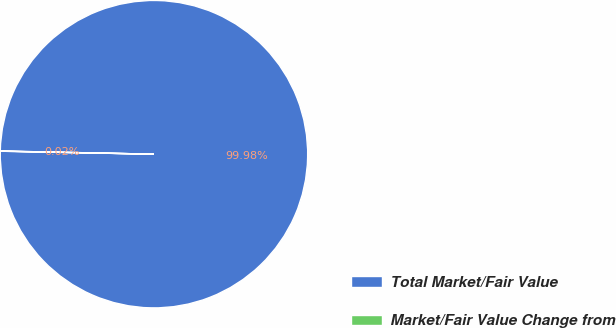Convert chart to OTSL. <chart><loc_0><loc_0><loc_500><loc_500><pie_chart><fcel>Total Market/Fair Value<fcel>Market/Fair Value Change from<nl><fcel>99.98%<fcel>0.02%<nl></chart> 